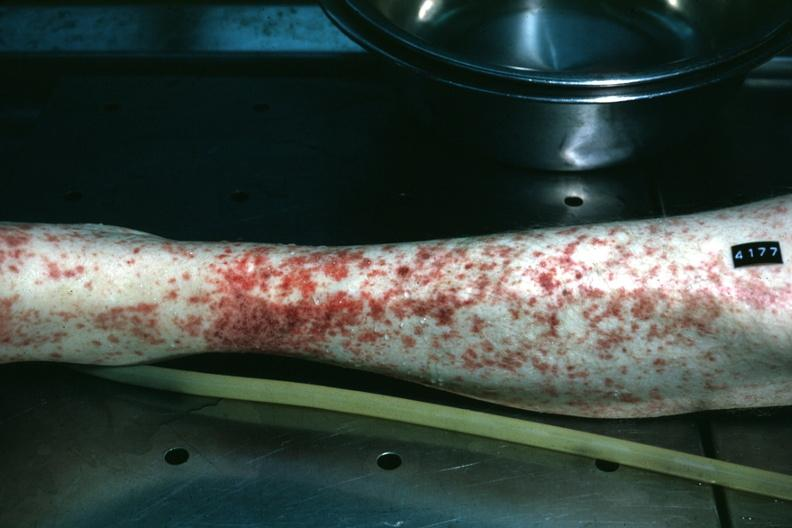where is this?
Answer the question using a single word or phrase. Skin 